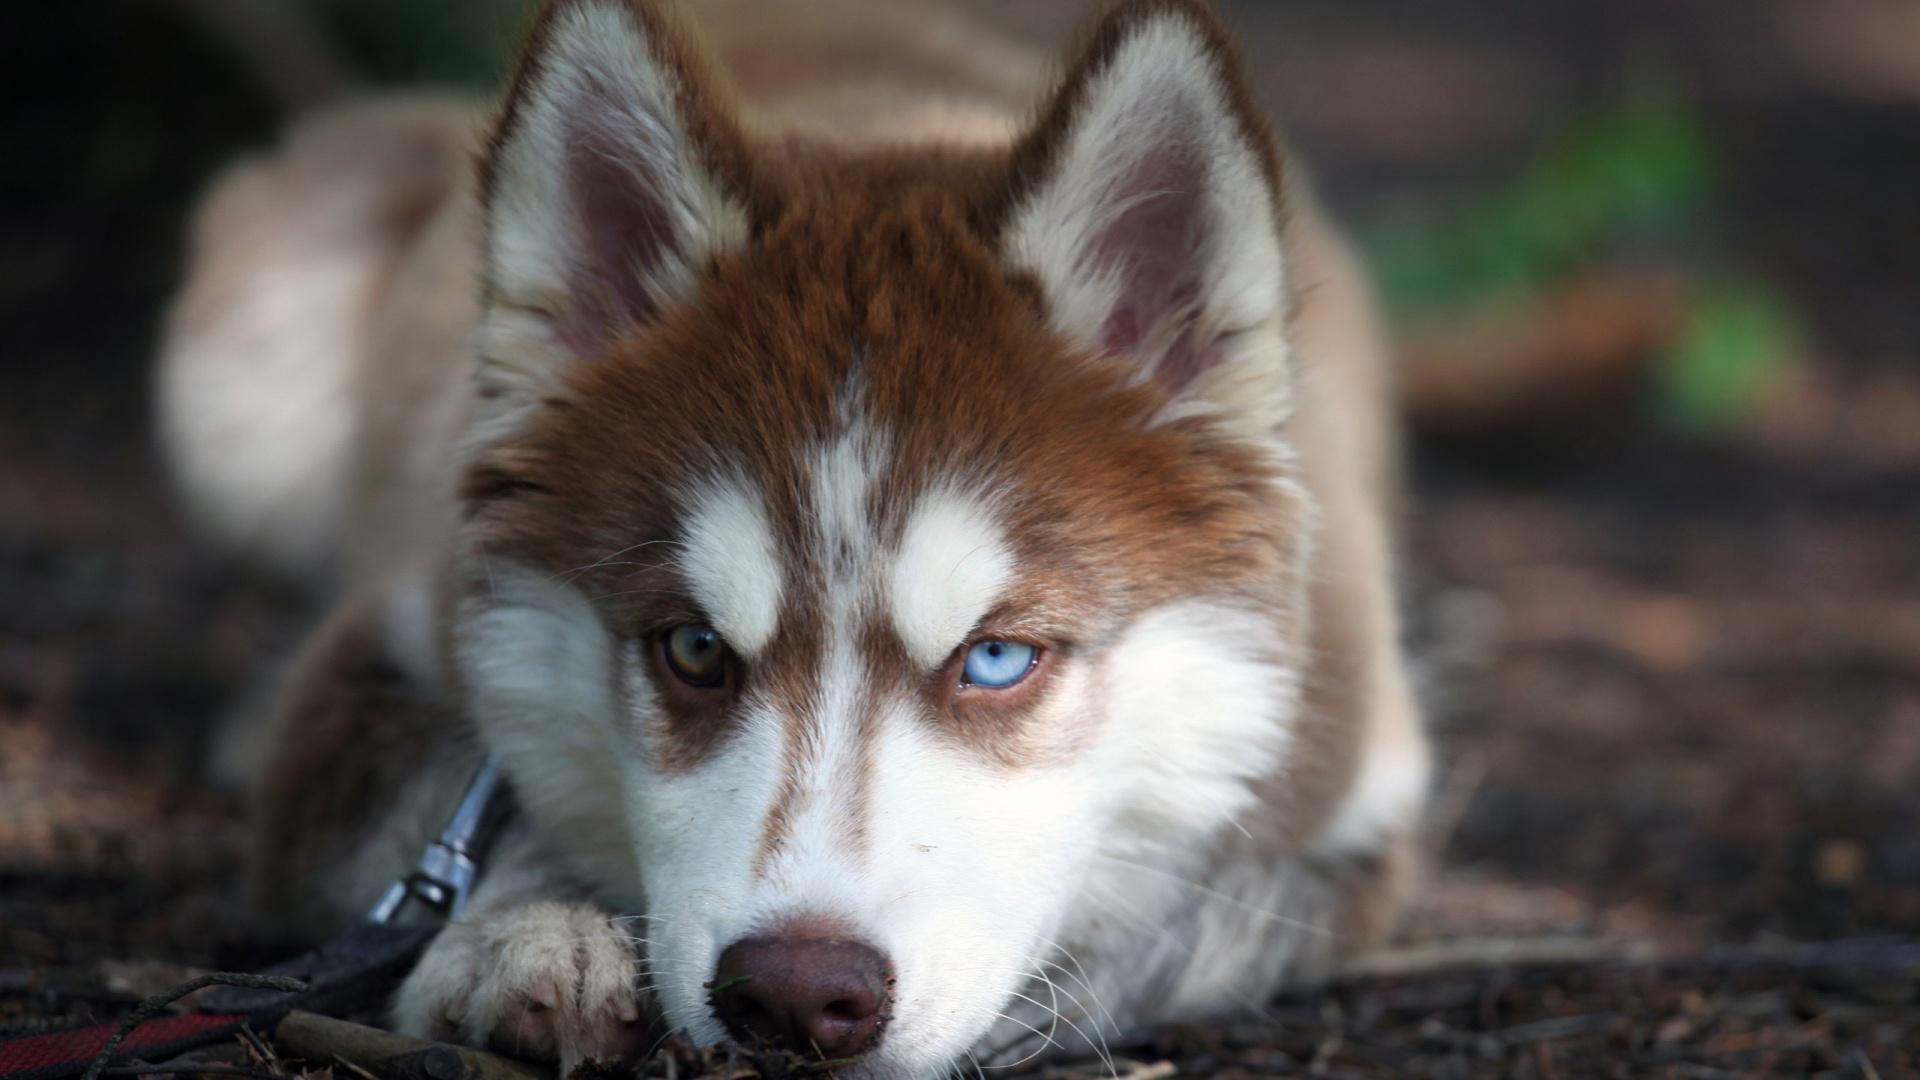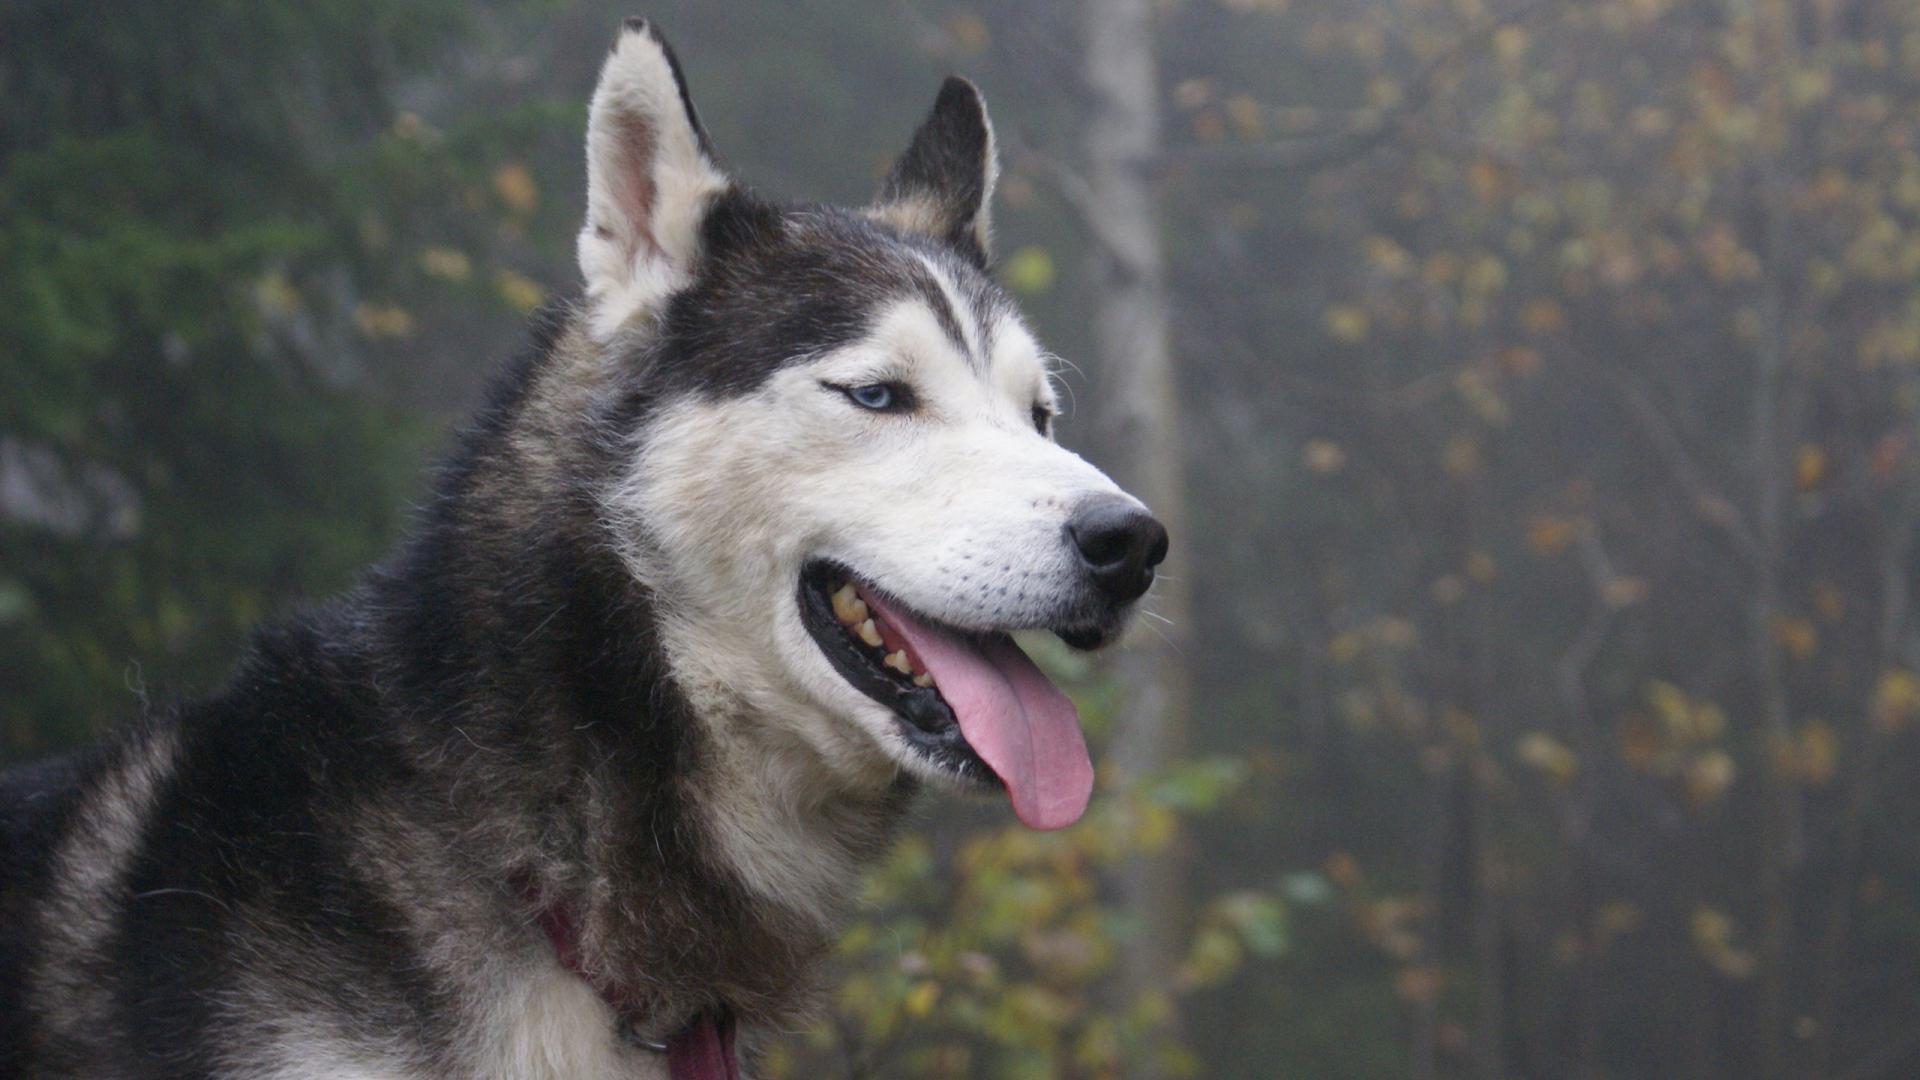The first image is the image on the left, the second image is the image on the right. For the images shown, is this caption "The right image contains exactly two dogs." true? Answer yes or no. No. The first image is the image on the left, the second image is the image on the right. Assess this claim about the two images: "The right image shows two husky dogs of similar age and size, posed with their heads side-by-side, showing similar expressions.". Correct or not? Answer yes or no. No. 